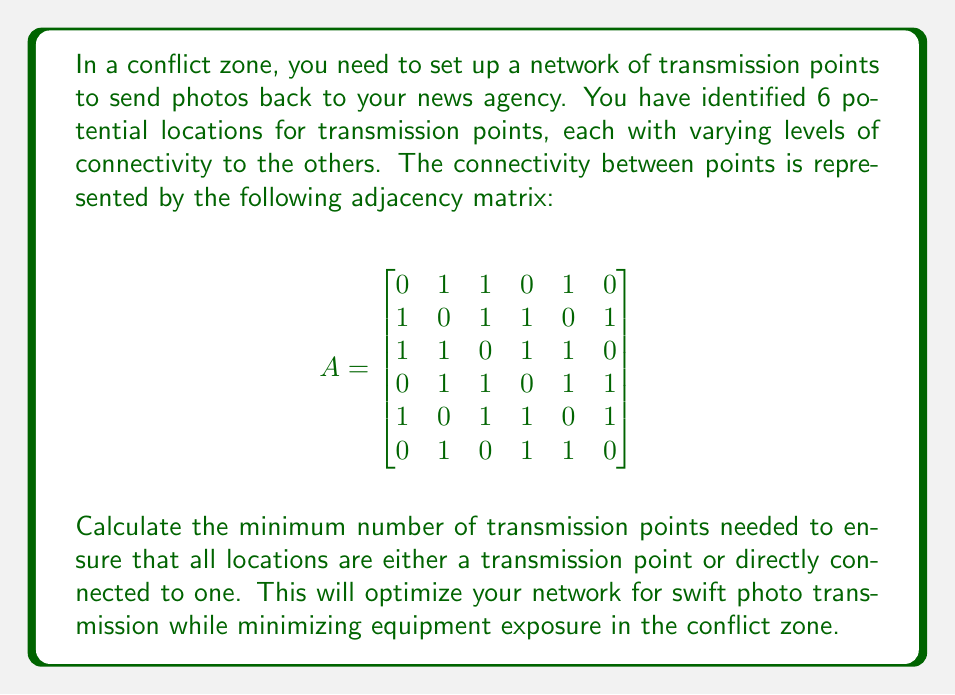Give your solution to this math problem. To solve this problem, we need to find the minimum dominating set in the graph represented by the given adjacency matrix. A dominating set is a subset of vertices in a graph such that every vertex not in the subset is adjacent to at least one vertex in the subset.

Let's approach this step-by-step:

1) First, we need to understand the graph structure. Each row (or column) in the adjacency matrix represents a location, and a 1 indicates a connection between locations.

2) We can use a greedy algorithm to find an approximate solution for the minimum dominating set:

   a) Start with all nodes unmarked.
   b) While there are unmarked nodes:
      - Choose the node that covers the most unmarked nodes (including itself).
      - Mark this node and all its neighbors as covered.
   c) The chosen nodes form our dominating set.

3) Let's apply this algorithm:

   Round 1: Node 3 covers the most unmarked nodes (5). Choose it.
   Marked nodes: 1, 2, 3, 4, 5

   Round 2: Of the remaining unmarked nodes (6), node 6 covers itself.
   Marked nodes: 1, 2, 3, 4, 5, 6

4) The algorithm terminates as all nodes are now marked.

5) Our dominating set consists of nodes 3 and 6, which means we need 2 transmission points.

6) We can verify that this is indeed a dominating set:
   - Node 3 covers nodes 1, 2, 3, 4, 5
   - Node 6 covers itself and is also connected to nodes 2, 4, 5

Therefore, placing transmission points at locations 3 and 6 ensures that all locations are either a transmission point or directly connected to one.
Answer: The minimum number of transmission points needed is 2. 